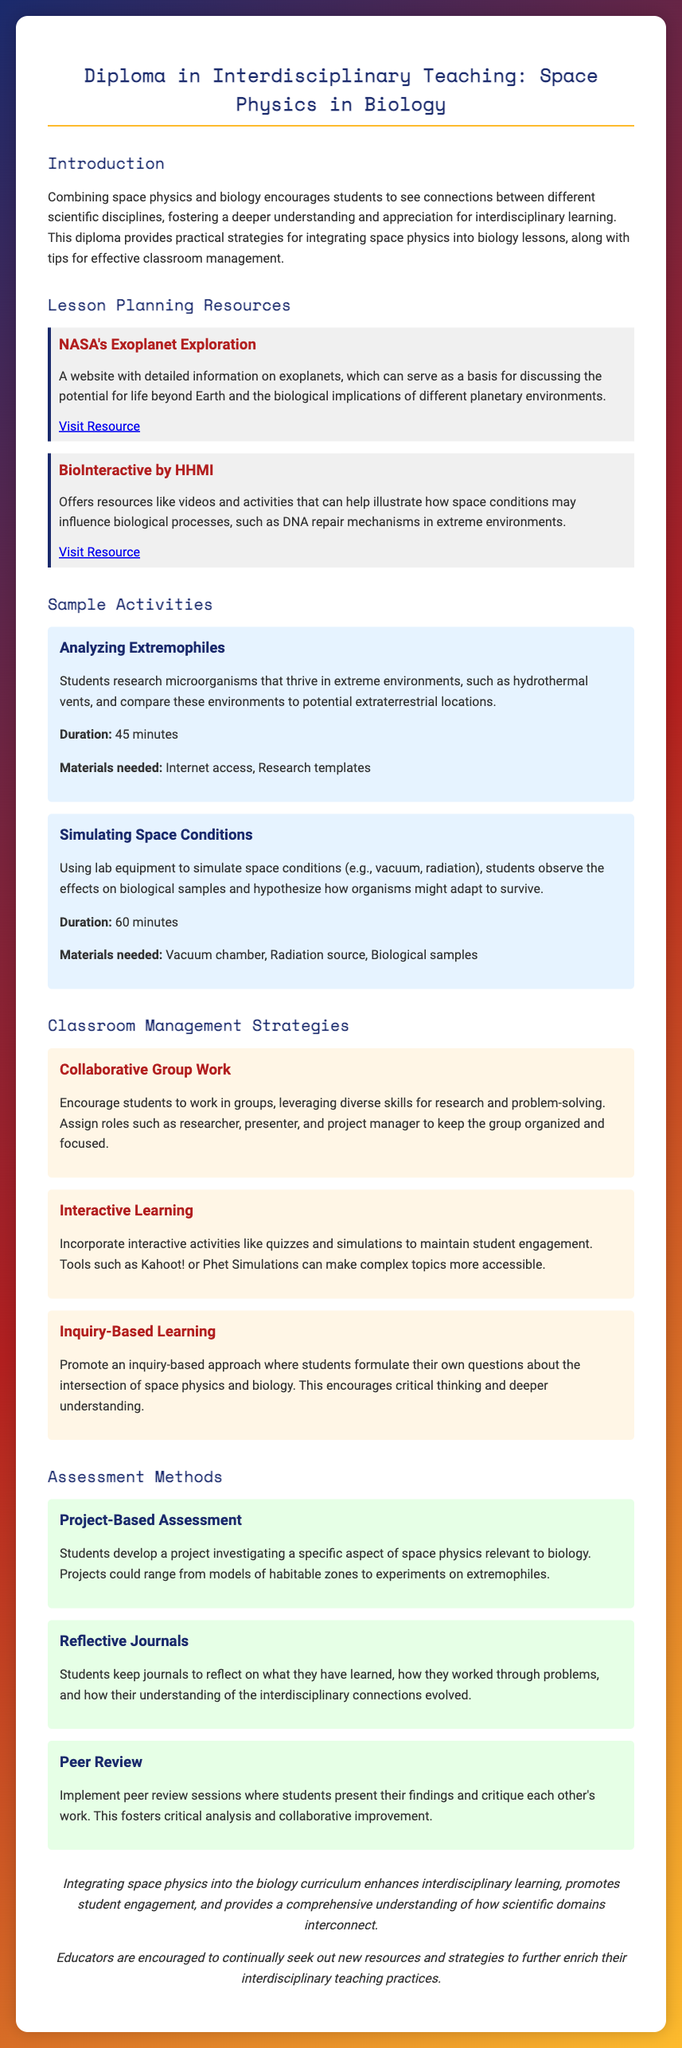What is the title of the diploma? The title of the diploma is presented prominently at the top of the document.
Answer: Diploma in Interdisciplinary Teaching: Space Physics in Biology Name one resource for lesson planning provided in the document. The document lists specific resources under the Lesson Planning Resources section.
Answer: NASA's Exoplanet Exploration What is the duration of the "Simulating Space Conditions" activity? The duration for each sample activity is stated clearly underneath the activity descriptions.
Answer: 60 minutes What teaching strategy encourages students to work in groups? The document outlines various classroom management strategies, including collaborative group work.
Answer: Collaborative Group Work What type of assessment involves students presenting their findings? The document describes different assessment methods and specifies which ones require presentations.
Answer: Peer Review How many sample activities are mentioned in the document? The document lists two specific activities as examples within the Sample Activities section.
Answer: 2 What does the inquiry-based learning strategy promote? This strategy is outlined in the Classroom Management Strategies section, highlighting its key focus.
Answer: Critical thinking What is one biological implication discussed in the lesson planning resources? The document provides insights on biological implications relating to space conditions through specific resources.
Answer: Life beyond Earth 